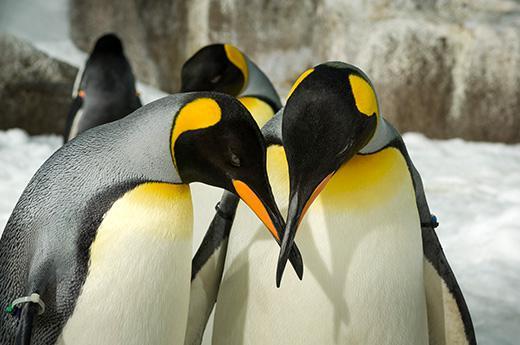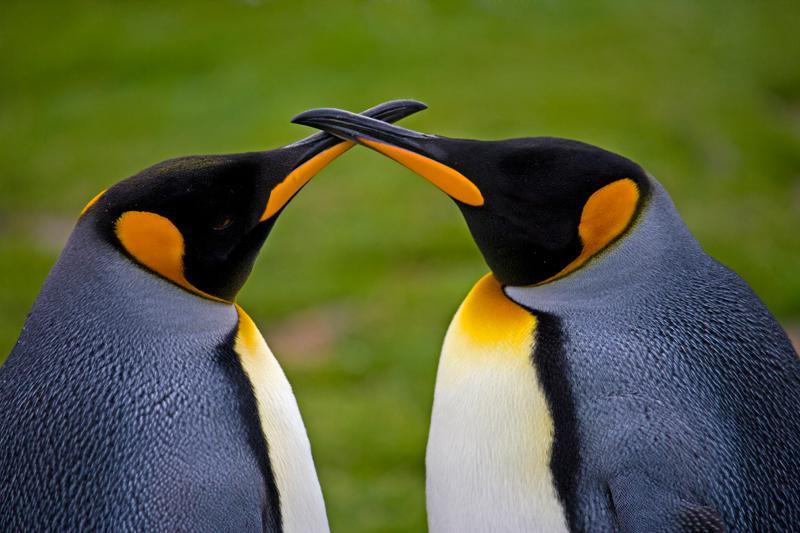The first image is the image on the left, the second image is the image on the right. For the images displayed, is the sentence "There are two penguins with crossed beaks in at least one of the images." factually correct? Answer yes or no. Yes. 